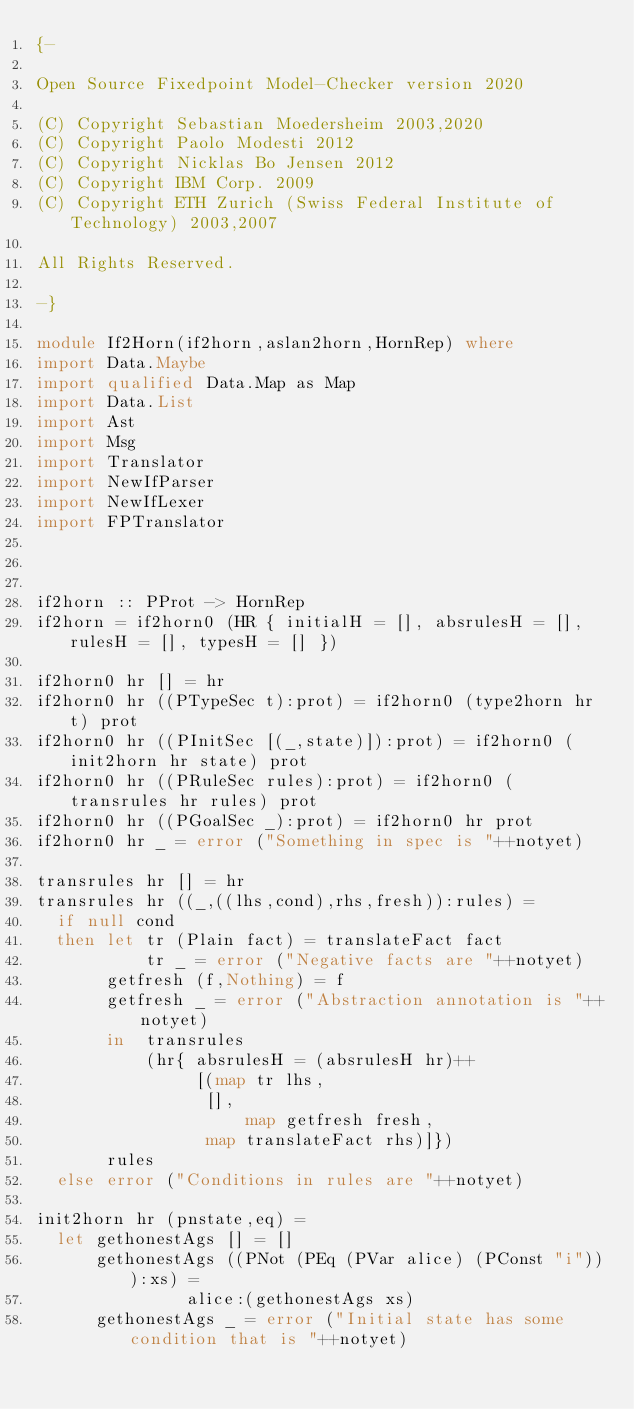<code> <loc_0><loc_0><loc_500><loc_500><_Haskell_>{-

Open Source Fixedpoint Model-Checker version 2020

(C) Copyright Sebastian Moedersheim 2003,2020
(C) Copyright Paolo Modesti 2012
(C) Copyright Nicklas Bo Jensen 2012
(C) Copyright IBM Corp. 2009
(C) Copyright ETH Zurich (Swiss Federal Institute of Technology) 2003,2007

All Rights Reserved.

-}

module If2Horn(if2horn,aslan2horn,HornRep) where
import Data.Maybe
import qualified Data.Map as Map
import Data.List
import Ast
import Msg
import Translator
import NewIfParser
import NewIfLexer
import FPTranslator



if2horn :: PProt -> HornRep
if2horn = if2horn0 (HR { initialH = [], absrulesH = [], rulesH = [], typesH = [] })

if2horn0 hr [] = hr
if2horn0 hr ((PTypeSec t):prot) = if2horn0 (type2horn hr t) prot
if2horn0 hr ((PInitSec [(_,state)]):prot) = if2horn0 (init2horn hr state) prot
if2horn0 hr ((PRuleSec rules):prot) = if2horn0 (transrules hr rules) prot
if2horn0 hr ((PGoalSec _):prot) = if2horn0 hr prot
if2horn0 hr _ = error ("Something in spec is "++notyet)

transrules hr [] = hr
transrules hr ((_,((lhs,cond),rhs,fresh)):rules) = 
  if null cond
  then let tr (Plain fact) = translateFact fact
           tr _ = error ("Negative facts are "++notyet)	
	   getfresh (f,Nothing) = f
	   getfresh _ = error ("Abstraction annotation is "++notyet)
       in  transrules 
       	   (hr{ absrulesH = (absrulesH hr)++
	   		    [(map tr lhs,
			     [],
	   	       	     map getfresh fresh,
			     map translateFact rhs)]})
	   rules
  else error ("Conditions in rules are "++notyet)

init2horn hr (pnstate,eq) = 
  let gethonestAgs [] = []
      gethonestAgs ((PNot (PEq (PVar alice) (PConst "i"))):xs) = 
      		   alice:(gethonestAgs xs)
      gethonestAgs _ = error ("Initial state has some condition that is "++notyet)</code> 